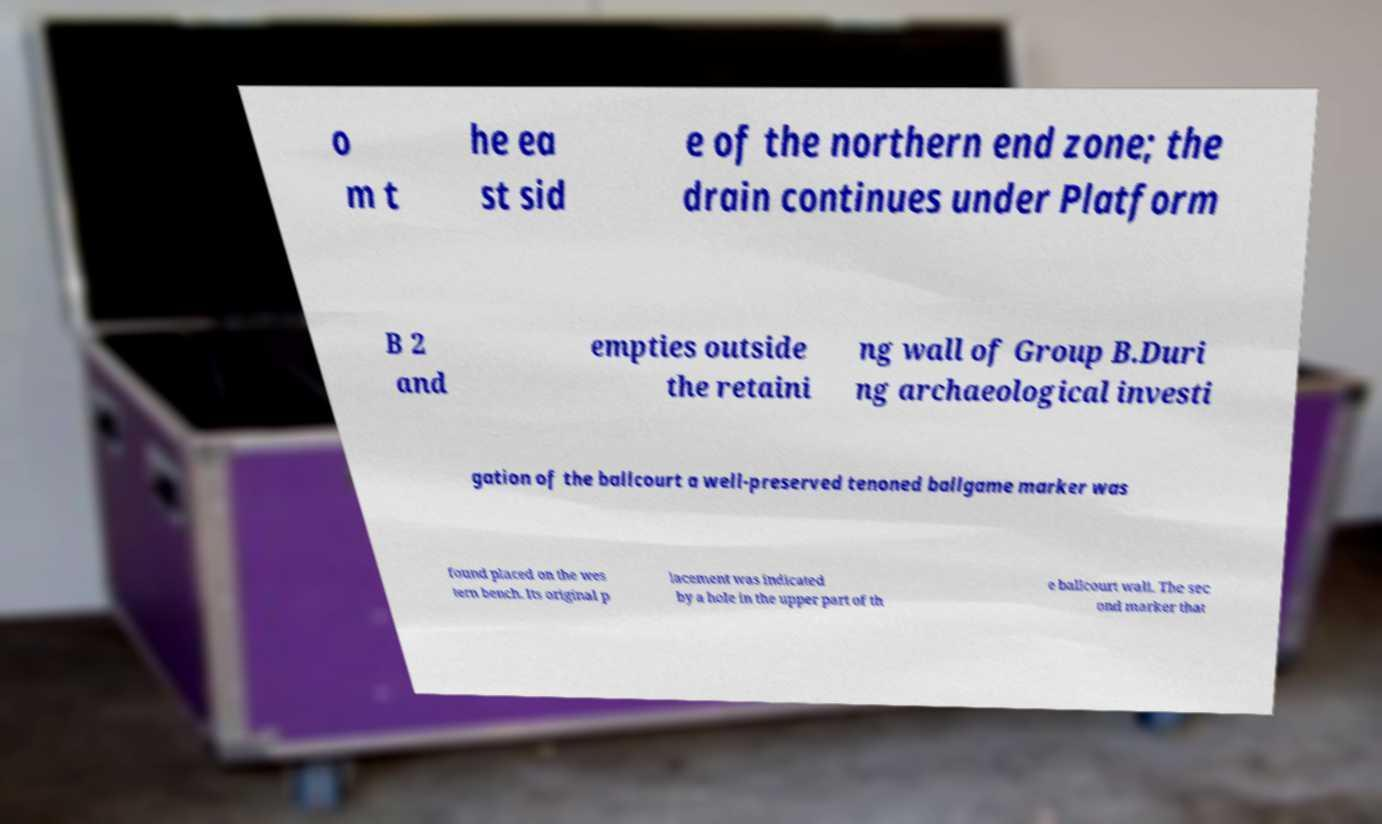Can you accurately transcribe the text from the provided image for me? o m t he ea st sid e of the northern end zone; the drain continues under Platform B 2 and empties outside the retaini ng wall of Group B.Duri ng archaeological investi gation of the ballcourt a well-preserved tenoned ballgame marker was found placed on the wes tern bench. Its original p lacement was indicated by a hole in the upper part of th e ballcourt wall. The sec ond marker that 